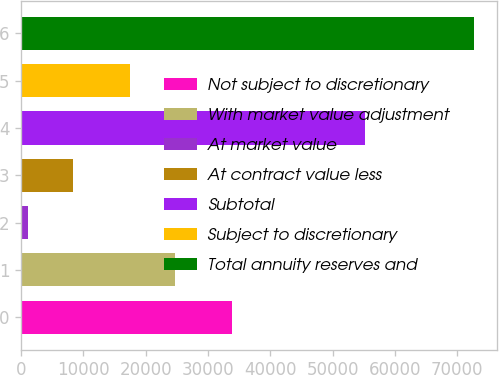<chart> <loc_0><loc_0><loc_500><loc_500><bar_chart><fcel>Not subject to discretionary<fcel>With market value adjustment<fcel>At market value<fcel>At contract value less<fcel>Subtotal<fcel>Subject to discretionary<fcel>Total annuity reserves and<nl><fcel>33837<fcel>24663.3<fcel>1162<fcel>8319.3<fcel>55229<fcel>17506<fcel>72735<nl></chart> 